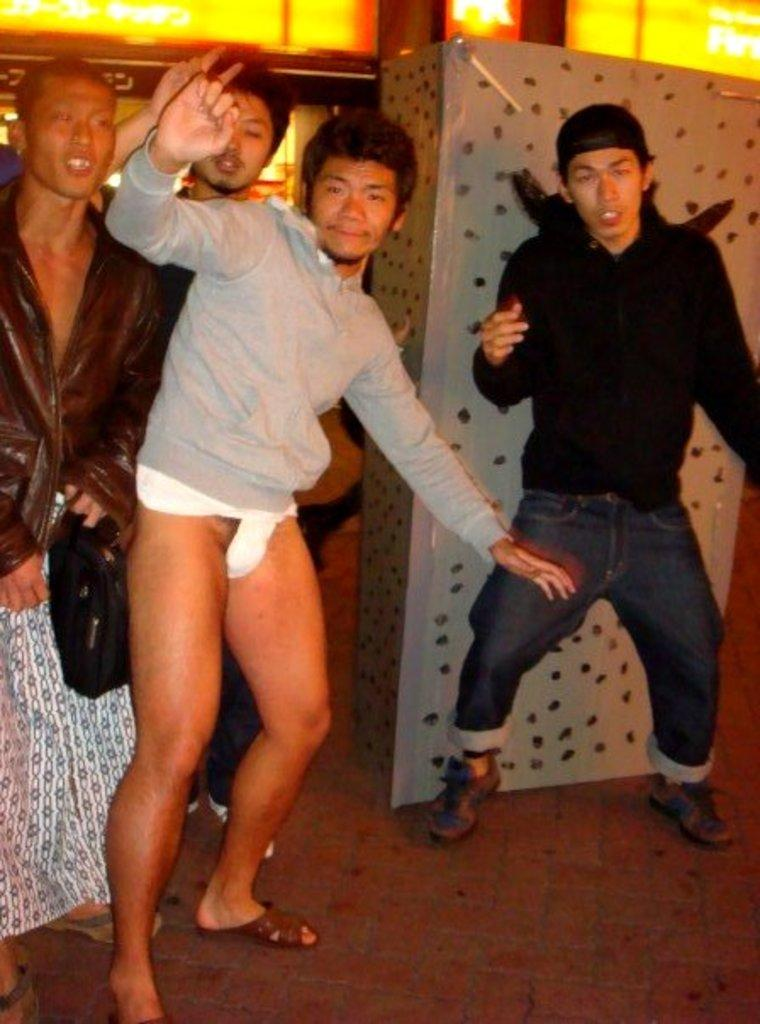How many people are in the image? There is a group of people standing in the image. What can be seen in the background of the image? There are boards visible in the background of the image. What material is the metal object made of? There is a metal object in the image. What is the surface that the people are standing on? There is a floor in the image. What type of request can be seen on the bedroom wall in the image? There is no bedroom or request present in the image. 